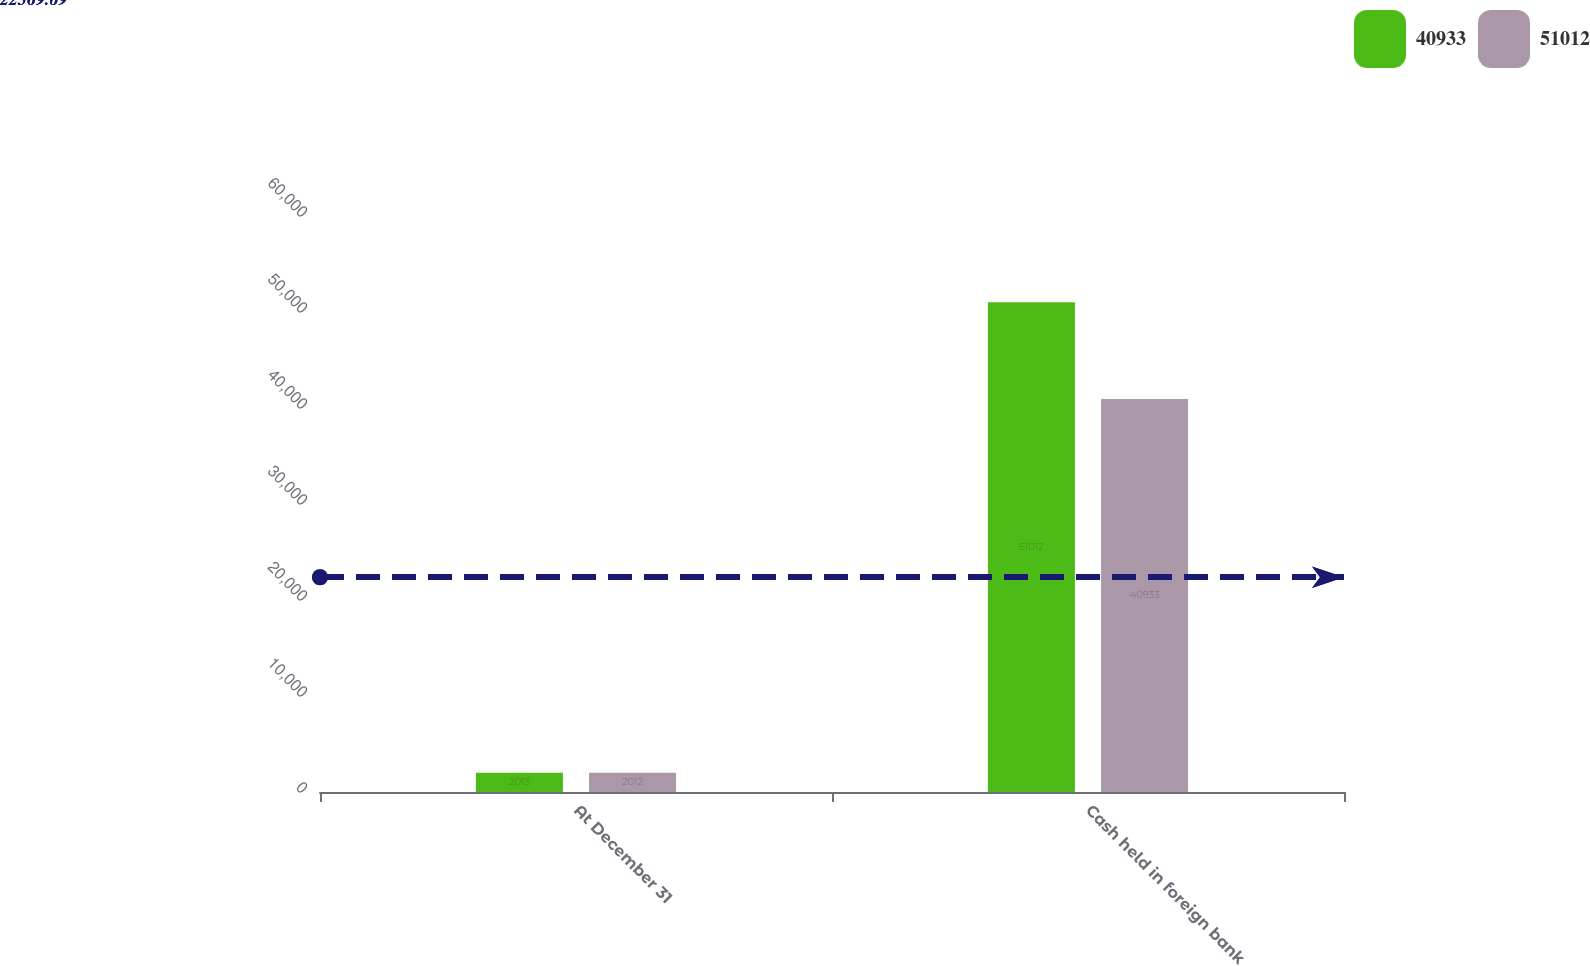<chart> <loc_0><loc_0><loc_500><loc_500><stacked_bar_chart><ecel><fcel>At December 31<fcel>Cash held in foreign bank<nl><fcel>40933<fcel>2013<fcel>51012<nl><fcel>51012<fcel>2012<fcel>40933<nl></chart> 